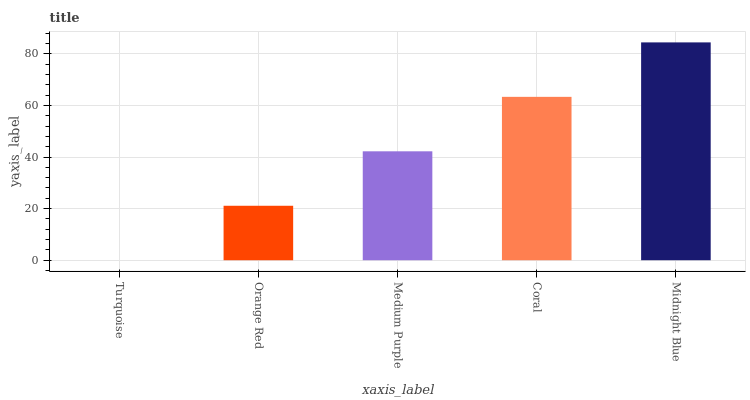Is Turquoise the minimum?
Answer yes or no. Yes. Is Midnight Blue the maximum?
Answer yes or no. Yes. Is Orange Red the minimum?
Answer yes or no. No. Is Orange Red the maximum?
Answer yes or no. No. Is Orange Red greater than Turquoise?
Answer yes or no. Yes. Is Turquoise less than Orange Red?
Answer yes or no. Yes. Is Turquoise greater than Orange Red?
Answer yes or no. No. Is Orange Red less than Turquoise?
Answer yes or no. No. Is Medium Purple the high median?
Answer yes or no. Yes. Is Medium Purple the low median?
Answer yes or no. Yes. Is Orange Red the high median?
Answer yes or no. No. Is Orange Red the low median?
Answer yes or no. No. 